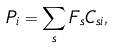<formula> <loc_0><loc_0><loc_500><loc_500>P _ { i } = \sum _ { s } F _ { s } C _ { s i } ,</formula> 